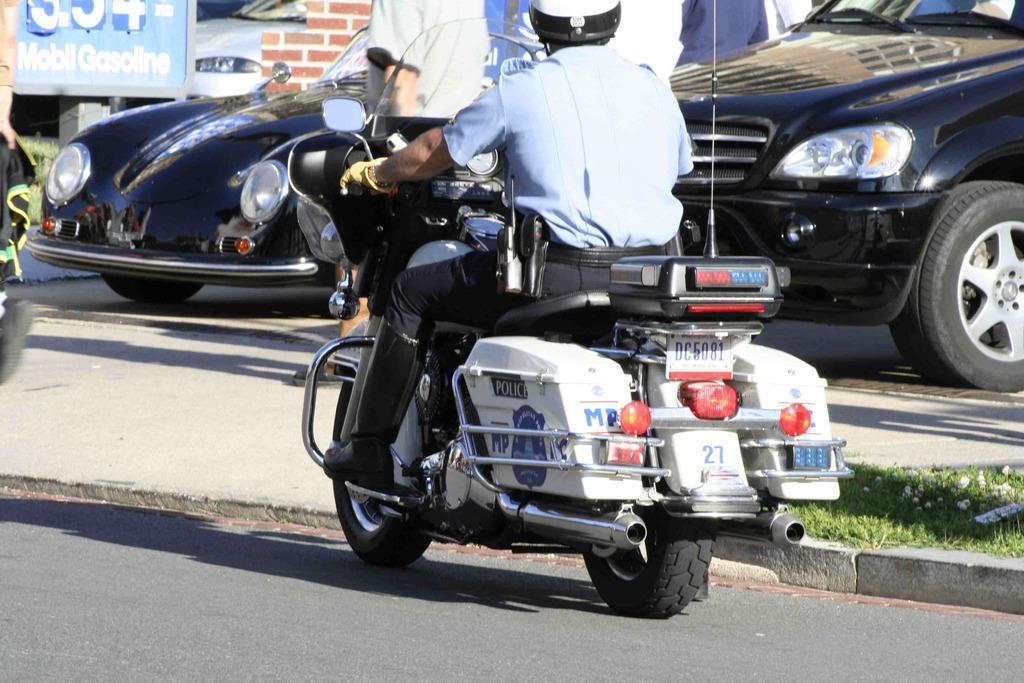What is the main feature of the image? There is a road in the image. What is the person in the image doing? The person is sitting on a vehicle. What can be seen in the background of the image? There are cars visible in the background, and there is a wall with text written on it. What type of cracker is the person eating while sitting on the vehicle? There is no cracker present in the image, and the person's actions do not involve eating. 